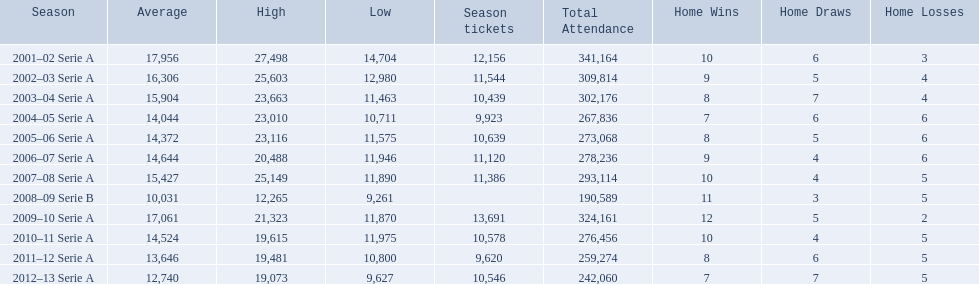What seasons were played at the stadio ennio tardini 2001–02 Serie A, 2002–03 Serie A, 2003–04 Serie A, 2004–05 Serie A, 2005–06 Serie A, 2006–07 Serie A, 2007–08 Serie A, 2008–09 Serie B, 2009–10 Serie A, 2010–11 Serie A, 2011–12 Serie A, 2012–13 Serie A. Which of these seasons had season tickets? 2001–02 Serie A, 2002–03 Serie A, 2003–04 Serie A, 2004–05 Serie A, 2005–06 Serie A, 2006–07 Serie A, 2007–08 Serie A, 2009–10 Serie A, 2010–11 Serie A, 2011–12 Serie A, 2012–13 Serie A. How many season tickets did the 2007-08 season have? 11,386. 